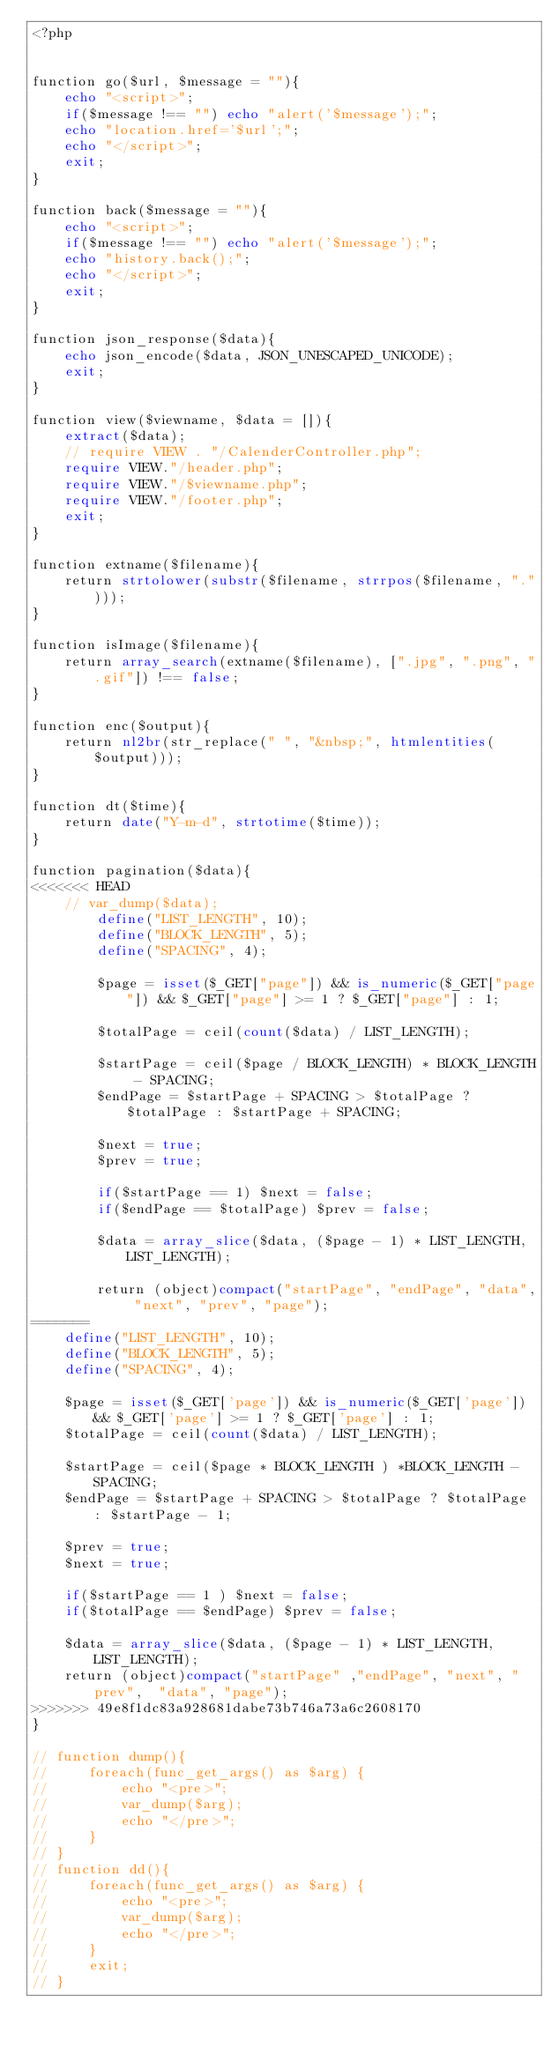Convert code to text. <code><loc_0><loc_0><loc_500><loc_500><_PHP_><?php


function go($url, $message = ""){
    echo "<script>";
    if($message !== "") echo "alert('$message');";
    echo "location.href='$url';";
    echo "</script>";
    exit;
}

function back($message = ""){
    echo "<script>";
    if($message !== "") echo "alert('$message');";
    echo "history.back();";
    echo "</script>";
    exit;
}

function json_response($data){
    echo json_encode($data, JSON_UNESCAPED_UNICODE);
    exit;
}

function view($viewname, $data = []){
    extract($data);
    // require VIEW . "/CalenderController.php";
    require VIEW."/header.php";
    require VIEW."/$viewname.php";
    require VIEW."/footer.php";
    exit;
}

function extname($filename){
    return strtolower(substr($filename, strrpos($filename, ".")));
}

function isImage($filename){
    return array_search(extname($filename), [".jpg", ".png", ".gif"]) !== false;
}

function enc($output){
    return nl2br(str_replace(" ", "&nbsp;", htmlentities($output)));
}

function dt($time){
    return date("Y-m-d", strtotime($time));
}

function pagination($data){
<<<<<<< HEAD
    // var_dump($data);
        define("LIST_LENGTH", 10);
        define("BLOCK_LENGTH", 5);
        define("SPACING", 4);
        
        $page = isset($_GET["page"]) && is_numeric($_GET["page"]) && $_GET["page"] >= 1 ? $_GET["page"] : 1;

        $totalPage = ceil(count($data) / LIST_LENGTH);
        
        $startPage = ceil($page / BLOCK_LENGTH) * BLOCK_LENGTH - SPACING;
        $endPage = $startPage + SPACING > $totalPage ? $totalPage : $startPage + SPACING;

        $next = true;
        $prev = true;

        if($startPage == 1) $next = false;
        if($endPage == $totalPage) $prev = false;

        $data = array_slice($data, ($page - 1) * LIST_LENGTH, LIST_LENGTH);

        return (object)compact("startPage", "endPage", "data", "next", "prev", "page");
=======
    define("LIST_LENGTH", 10);
    define("BLOCK_LENGTH", 5);
    define("SPACING", 4);
 
    $page = isset($_GET['page']) && is_numeric($_GET['page']) && $_GET['page'] >= 1 ? $_GET['page'] : 1;
    $totalPage = ceil(count($data) / LIST_LENGTH);

    $startPage = ceil($page * BLOCK_LENGTH ) *BLOCK_LENGTH - SPACING;
    $endPage = $startPage + SPACING > $totalPage ? $totalPage : $startPage - 1;

    $prev = true;
    $next = true;

    if($startPage == 1 ) $next = false;
    if($totalPage == $endPage) $prev = false;

    $data = array_slice($data, ($page - 1) * LIST_LENGTH, LIST_LENGTH);
    return (object)compact("startPage" ,"endPage", "next", "prev",  "data", "page");
>>>>>>> 49e8f1dc83a928681dabe73b746a73a6c2608170
}

// function dump(){
//     foreach(func_get_args() as $arg) {
//         echo "<pre>";
//         var_dump($arg);
//         echo "</pre>";
//     }
// }
// function dd(){
//     foreach(func_get_args() as $arg) {
//         echo "<pre>";
//         var_dump($arg);
//         echo "</pre>";
//     }
//     exit;
// }</code> 